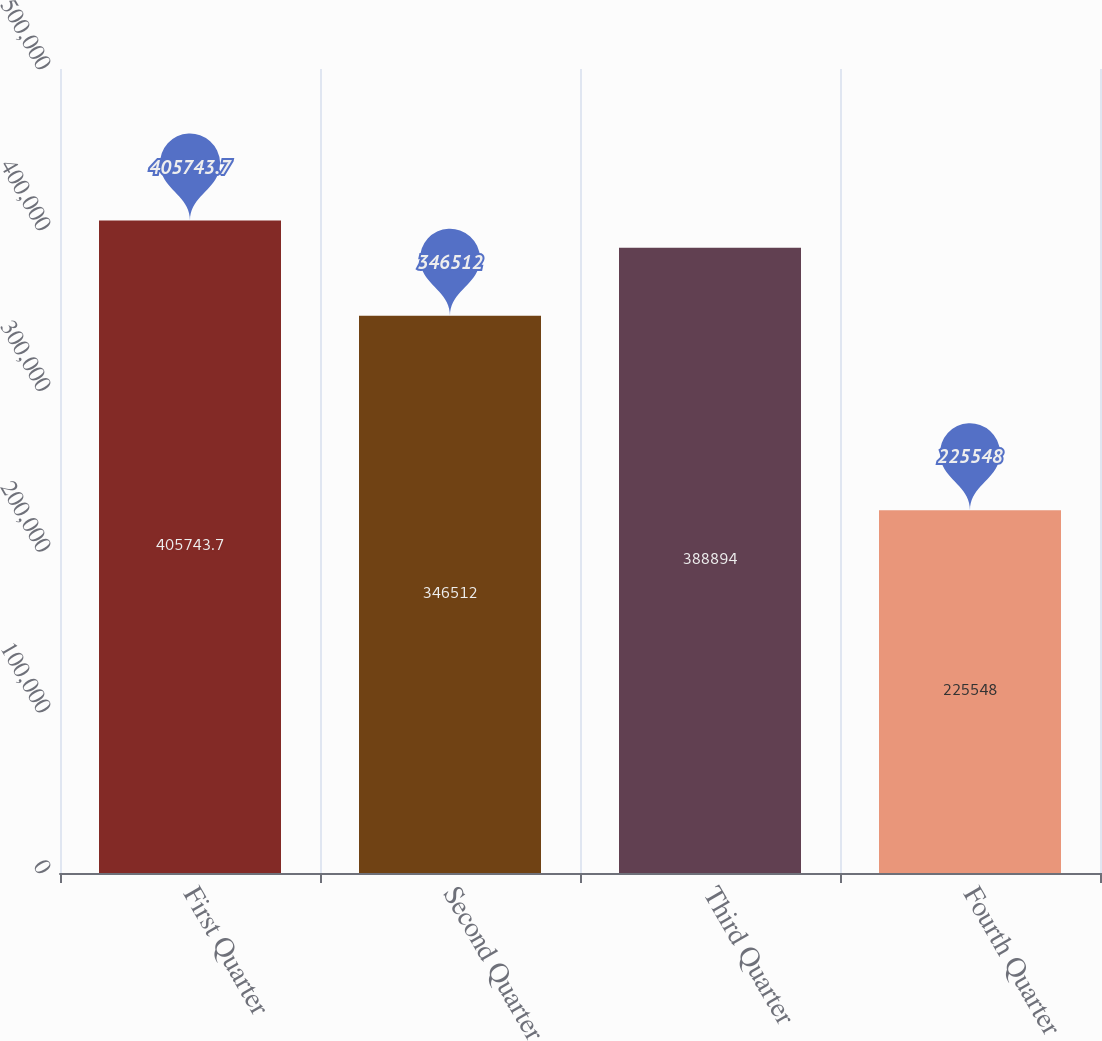Convert chart to OTSL. <chart><loc_0><loc_0><loc_500><loc_500><bar_chart><fcel>First Quarter<fcel>Second Quarter<fcel>Third Quarter<fcel>Fourth Quarter<nl><fcel>405744<fcel>346512<fcel>388894<fcel>225548<nl></chart> 